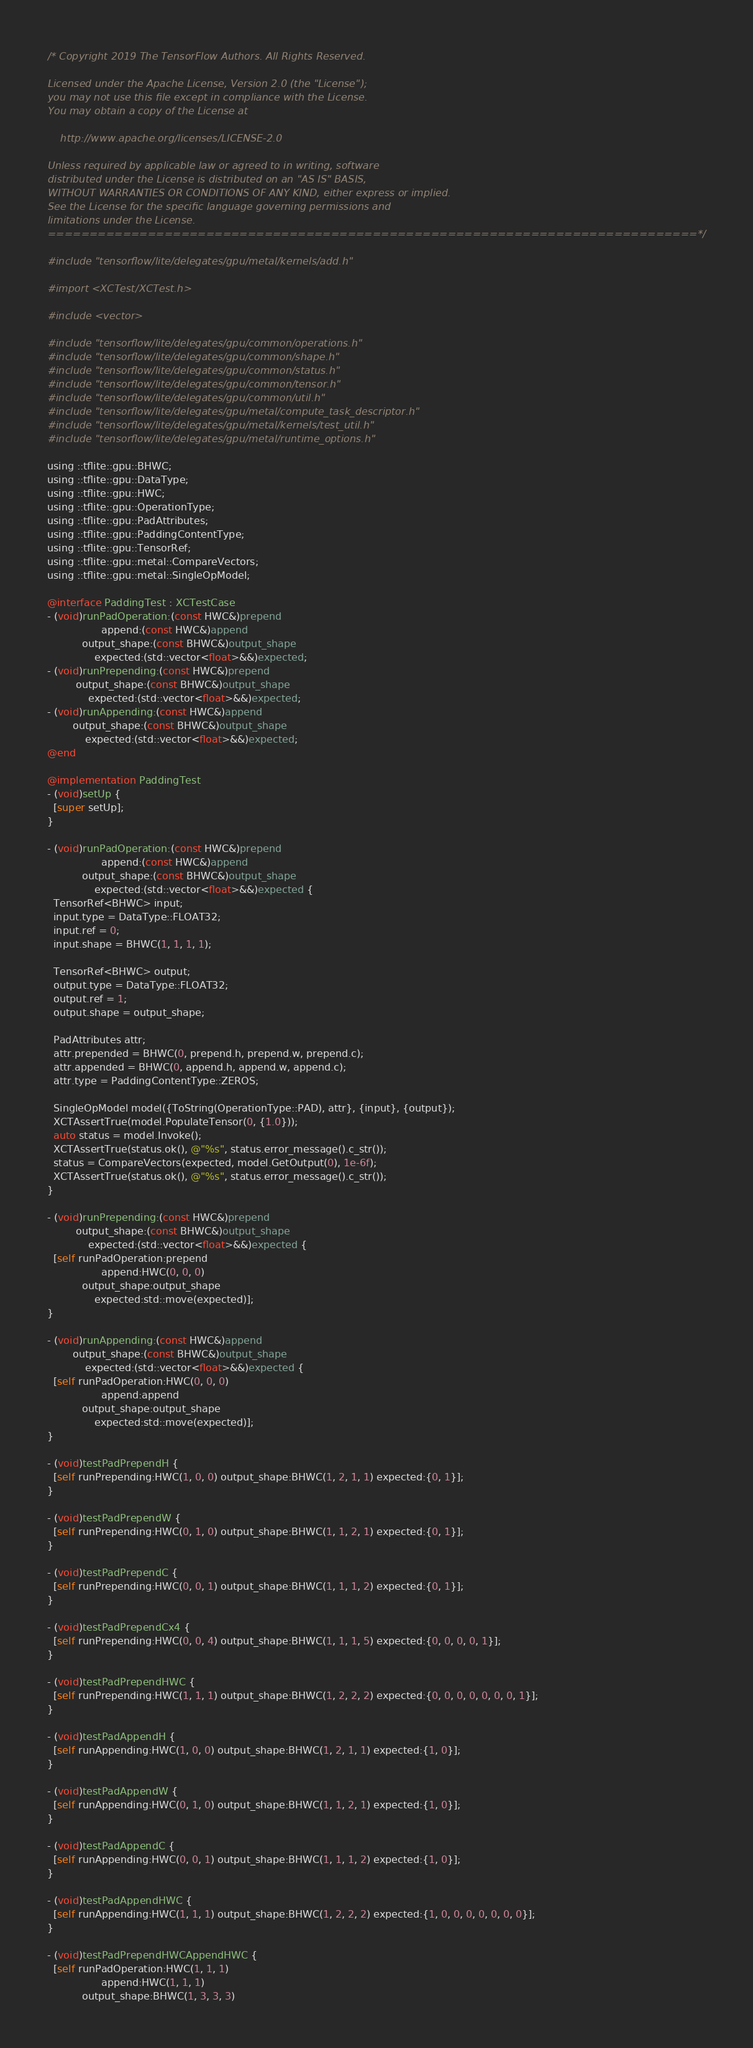<code> <loc_0><loc_0><loc_500><loc_500><_ObjectiveC_>/* Copyright 2019 The TensorFlow Authors. All Rights Reserved.

Licensed under the Apache License, Version 2.0 (the "License");
you may not use this file except in compliance with the License.
You may obtain a copy of the License at

    http://www.apache.org/licenses/LICENSE-2.0

Unless required by applicable law or agreed to in writing, software
distributed under the License is distributed on an "AS IS" BASIS,
WITHOUT WARRANTIES OR CONDITIONS OF ANY KIND, either express or implied.
See the License for the specific language governing permissions and
limitations under the License.
==============================================================================*/

#include "tensorflow/lite/delegates/gpu/metal/kernels/add.h"

#import <XCTest/XCTest.h>

#include <vector>

#include "tensorflow/lite/delegates/gpu/common/operations.h"
#include "tensorflow/lite/delegates/gpu/common/shape.h"
#include "tensorflow/lite/delegates/gpu/common/status.h"
#include "tensorflow/lite/delegates/gpu/common/tensor.h"
#include "tensorflow/lite/delegates/gpu/common/util.h"
#include "tensorflow/lite/delegates/gpu/metal/compute_task_descriptor.h"
#include "tensorflow/lite/delegates/gpu/metal/kernels/test_util.h"
#include "tensorflow/lite/delegates/gpu/metal/runtime_options.h"

using ::tflite::gpu::BHWC;
using ::tflite::gpu::DataType;
using ::tflite::gpu::HWC;
using ::tflite::gpu::OperationType;
using ::tflite::gpu::PadAttributes;
using ::tflite::gpu::PaddingContentType;
using ::tflite::gpu::TensorRef;
using ::tflite::gpu::metal::CompareVectors;
using ::tflite::gpu::metal::SingleOpModel;

@interface PaddingTest : XCTestCase
- (void)runPadOperation:(const HWC&)prepend
                 append:(const HWC&)append
           output_shape:(const BHWC&)output_shape
               expected:(std::vector<float>&&)expected;
- (void)runPrepending:(const HWC&)prepend
         output_shape:(const BHWC&)output_shape
             expected:(std::vector<float>&&)expected;
- (void)runAppending:(const HWC&)append
        output_shape:(const BHWC&)output_shape
            expected:(std::vector<float>&&)expected;
@end

@implementation PaddingTest
- (void)setUp {
  [super setUp];
}

- (void)runPadOperation:(const HWC&)prepend
                 append:(const HWC&)append
           output_shape:(const BHWC&)output_shape
               expected:(std::vector<float>&&)expected {
  TensorRef<BHWC> input;
  input.type = DataType::FLOAT32;
  input.ref = 0;
  input.shape = BHWC(1, 1, 1, 1);

  TensorRef<BHWC> output;
  output.type = DataType::FLOAT32;
  output.ref = 1;
  output.shape = output_shape;

  PadAttributes attr;
  attr.prepended = BHWC(0, prepend.h, prepend.w, prepend.c);
  attr.appended = BHWC(0, append.h, append.w, append.c);
  attr.type = PaddingContentType::ZEROS;

  SingleOpModel model({ToString(OperationType::PAD), attr}, {input}, {output});
  XCTAssertTrue(model.PopulateTensor(0, {1.0}));
  auto status = model.Invoke();
  XCTAssertTrue(status.ok(), @"%s", status.error_message().c_str());
  status = CompareVectors(expected, model.GetOutput(0), 1e-6f);
  XCTAssertTrue(status.ok(), @"%s", status.error_message().c_str());
}

- (void)runPrepending:(const HWC&)prepend
         output_shape:(const BHWC&)output_shape
             expected:(std::vector<float>&&)expected {
  [self runPadOperation:prepend
                 append:HWC(0, 0, 0)
           output_shape:output_shape
               expected:std::move(expected)];
}

- (void)runAppending:(const HWC&)append
        output_shape:(const BHWC&)output_shape
            expected:(std::vector<float>&&)expected {
  [self runPadOperation:HWC(0, 0, 0)
                 append:append
           output_shape:output_shape
               expected:std::move(expected)];
}

- (void)testPadPrependH {
  [self runPrepending:HWC(1, 0, 0) output_shape:BHWC(1, 2, 1, 1) expected:{0, 1}];
}

- (void)testPadPrependW {
  [self runPrepending:HWC(0, 1, 0) output_shape:BHWC(1, 1, 2, 1) expected:{0, 1}];
}

- (void)testPadPrependC {
  [self runPrepending:HWC(0, 0, 1) output_shape:BHWC(1, 1, 1, 2) expected:{0, 1}];
}

- (void)testPadPrependCx4 {
  [self runPrepending:HWC(0, 0, 4) output_shape:BHWC(1, 1, 1, 5) expected:{0, 0, 0, 0, 1}];
}

- (void)testPadPrependHWC {
  [self runPrepending:HWC(1, 1, 1) output_shape:BHWC(1, 2, 2, 2) expected:{0, 0, 0, 0, 0, 0, 0, 1}];
}

- (void)testPadAppendH {
  [self runAppending:HWC(1, 0, 0) output_shape:BHWC(1, 2, 1, 1) expected:{1, 0}];
}

- (void)testPadAppendW {
  [self runAppending:HWC(0, 1, 0) output_shape:BHWC(1, 1, 2, 1) expected:{1, 0}];
}

- (void)testPadAppendC {
  [self runAppending:HWC(0, 0, 1) output_shape:BHWC(1, 1, 1, 2) expected:{1, 0}];
}

- (void)testPadAppendHWC {
  [self runAppending:HWC(1, 1, 1) output_shape:BHWC(1, 2, 2, 2) expected:{1, 0, 0, 0, 0, 0, 0, 0}];
}

- (void)testPadPrependHWCAppendHWC {
  [self runPadOperation:HWC(1, 1, 1)
                 append:HWC(1, 1, 1)
           output_shape:BHWC(1, 3, 3, 3)</code> 